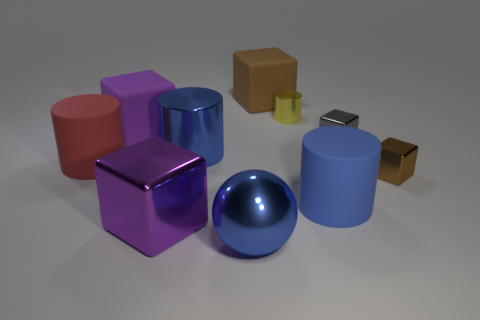Subtract all cyan spheres. How many blue cylinders are left? 2 Subtract all small yellow metal cylinders. How many cylinders are left? 3 Subtract all red cylinders. How many cylinders are left? 3 Subtract all balls. How many objects are left? 9 Subtract 2 cubes. How many cubes are left? 3 Add 8 small yellow blocks. How many small yellow blocks exist? 8 Subtract 0 yellow blocks. How many objects are left? 10 Subtract all purple cylinders. Subtract all yellow blocks. How many cylinders are left? 4 Subtract all large blue metal cylinders. Subtract all large metallic cylinders. How many objects are left? 8 Add 1 gray things. How many gray things are left? 2 